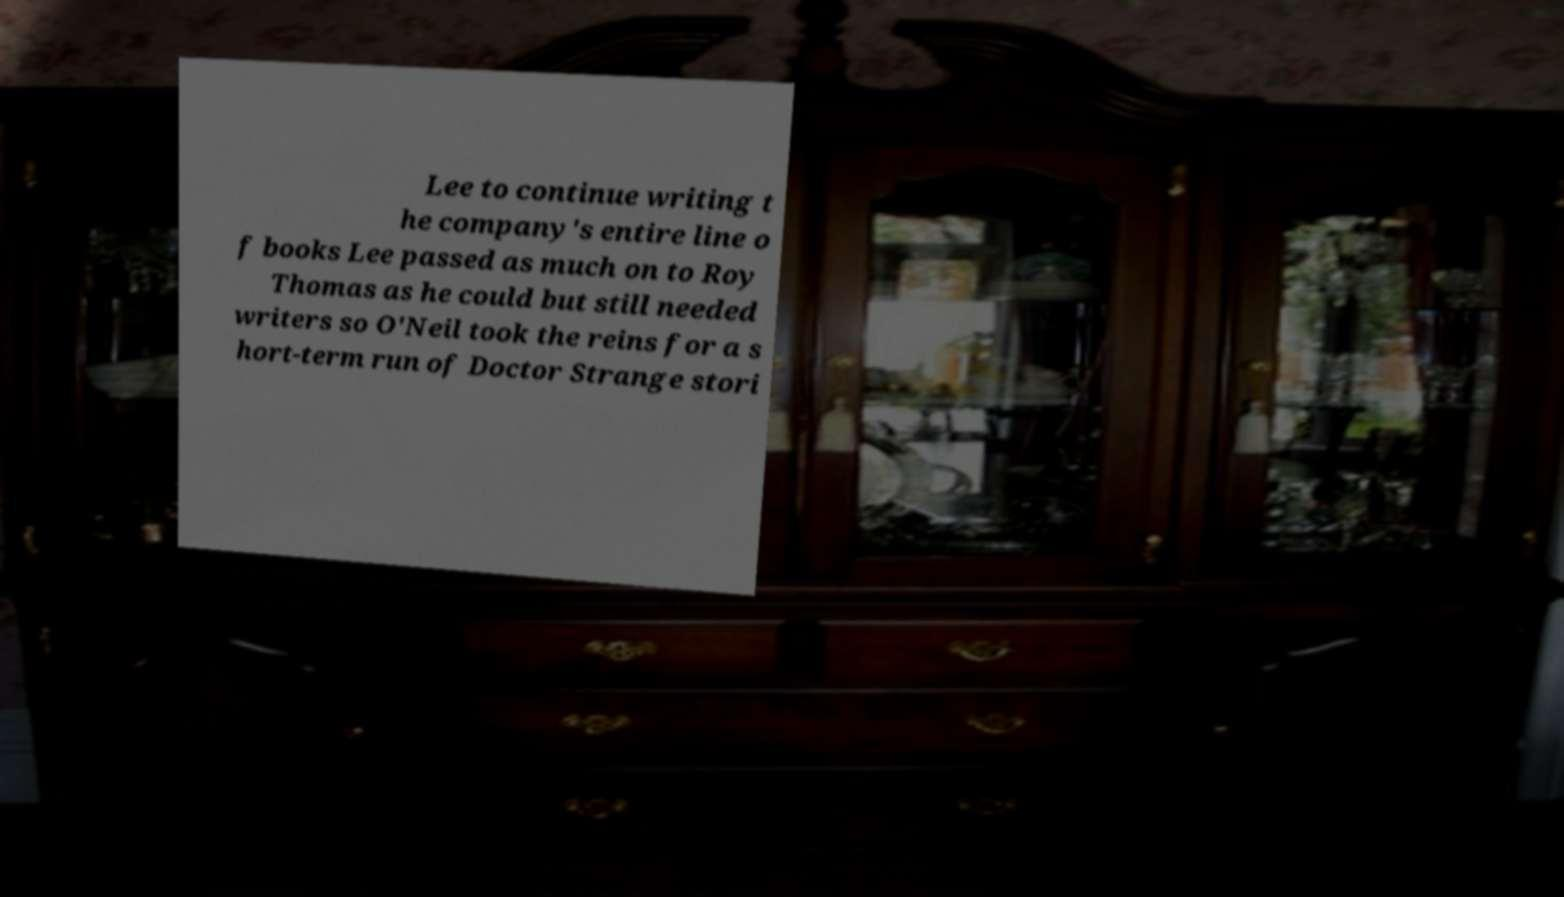Can you accurately transcribe the text from the provided image for me? Lee to continue writing t he company's entire line o f books Lee passed as much on to Roy Thomas as he could but still needed writers so O'Neil took the reins for a s hort-term run of Doctor Strange stori 